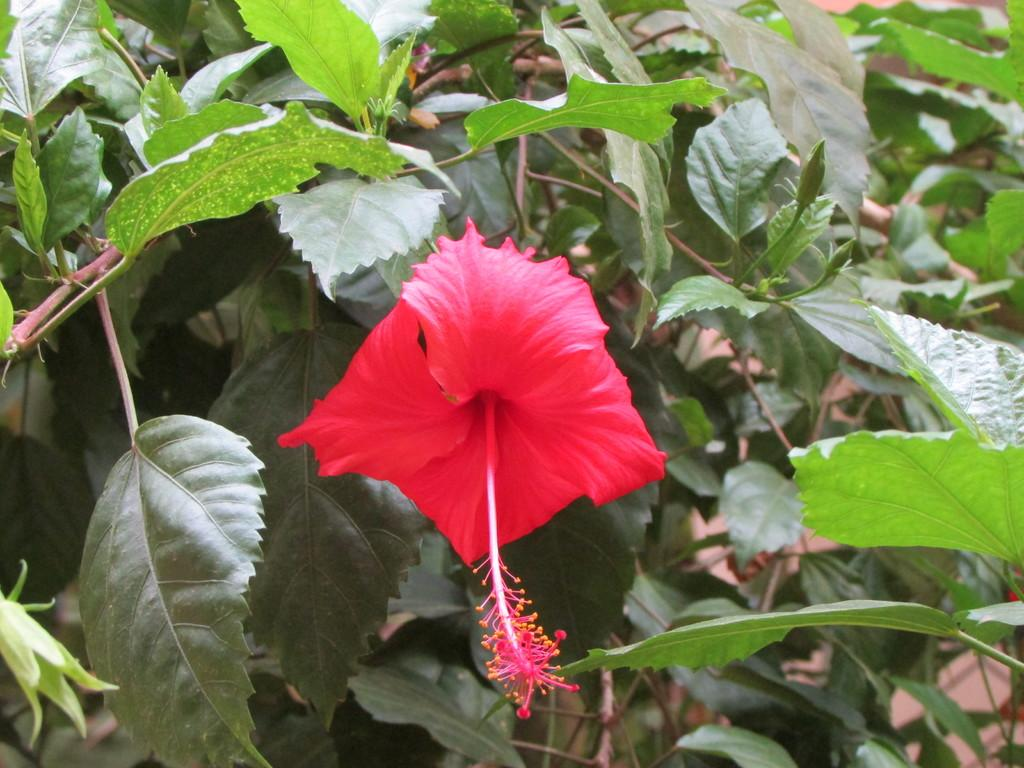What type of plant can be seen in the image? There is a flower in the image. What else is present on the plant besides the flower? There are leaves in the image. Can you see a mountain in the background of the image? There is no mountain visible in the image; it only features a flower and leaves. What type of horn is present on the flower in the image? There is no horn present on the flower in the image; it is a natural plant with a flower and leaves. 